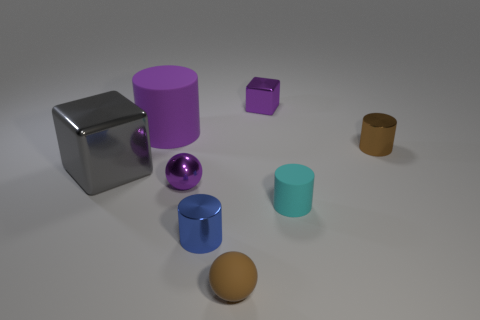Subtract all large purple cylinders. How many cylinders are left? 3 Subtract all purple cylinders. How many cylinders are left? 3 Subtract 2 cylinders. How many cylinders are left? 2 Subtract all blocks. How many objects are left? 6 Add 3 brown shiny cylinders. How many brown shiny cylinders are left? 4 Add 3 purple rubber cylinders. How many purple rubber cylinders exist? 4 Add 1 purple balls. How many objects exist? 9 Subtract 0 cyan spheres. How many objects are left? 8 Subtract all blue balls. Subtract all purple cylinders. How many balls are left? 2 Subtract all brown cylinders. How many purple blocks are left? 1 